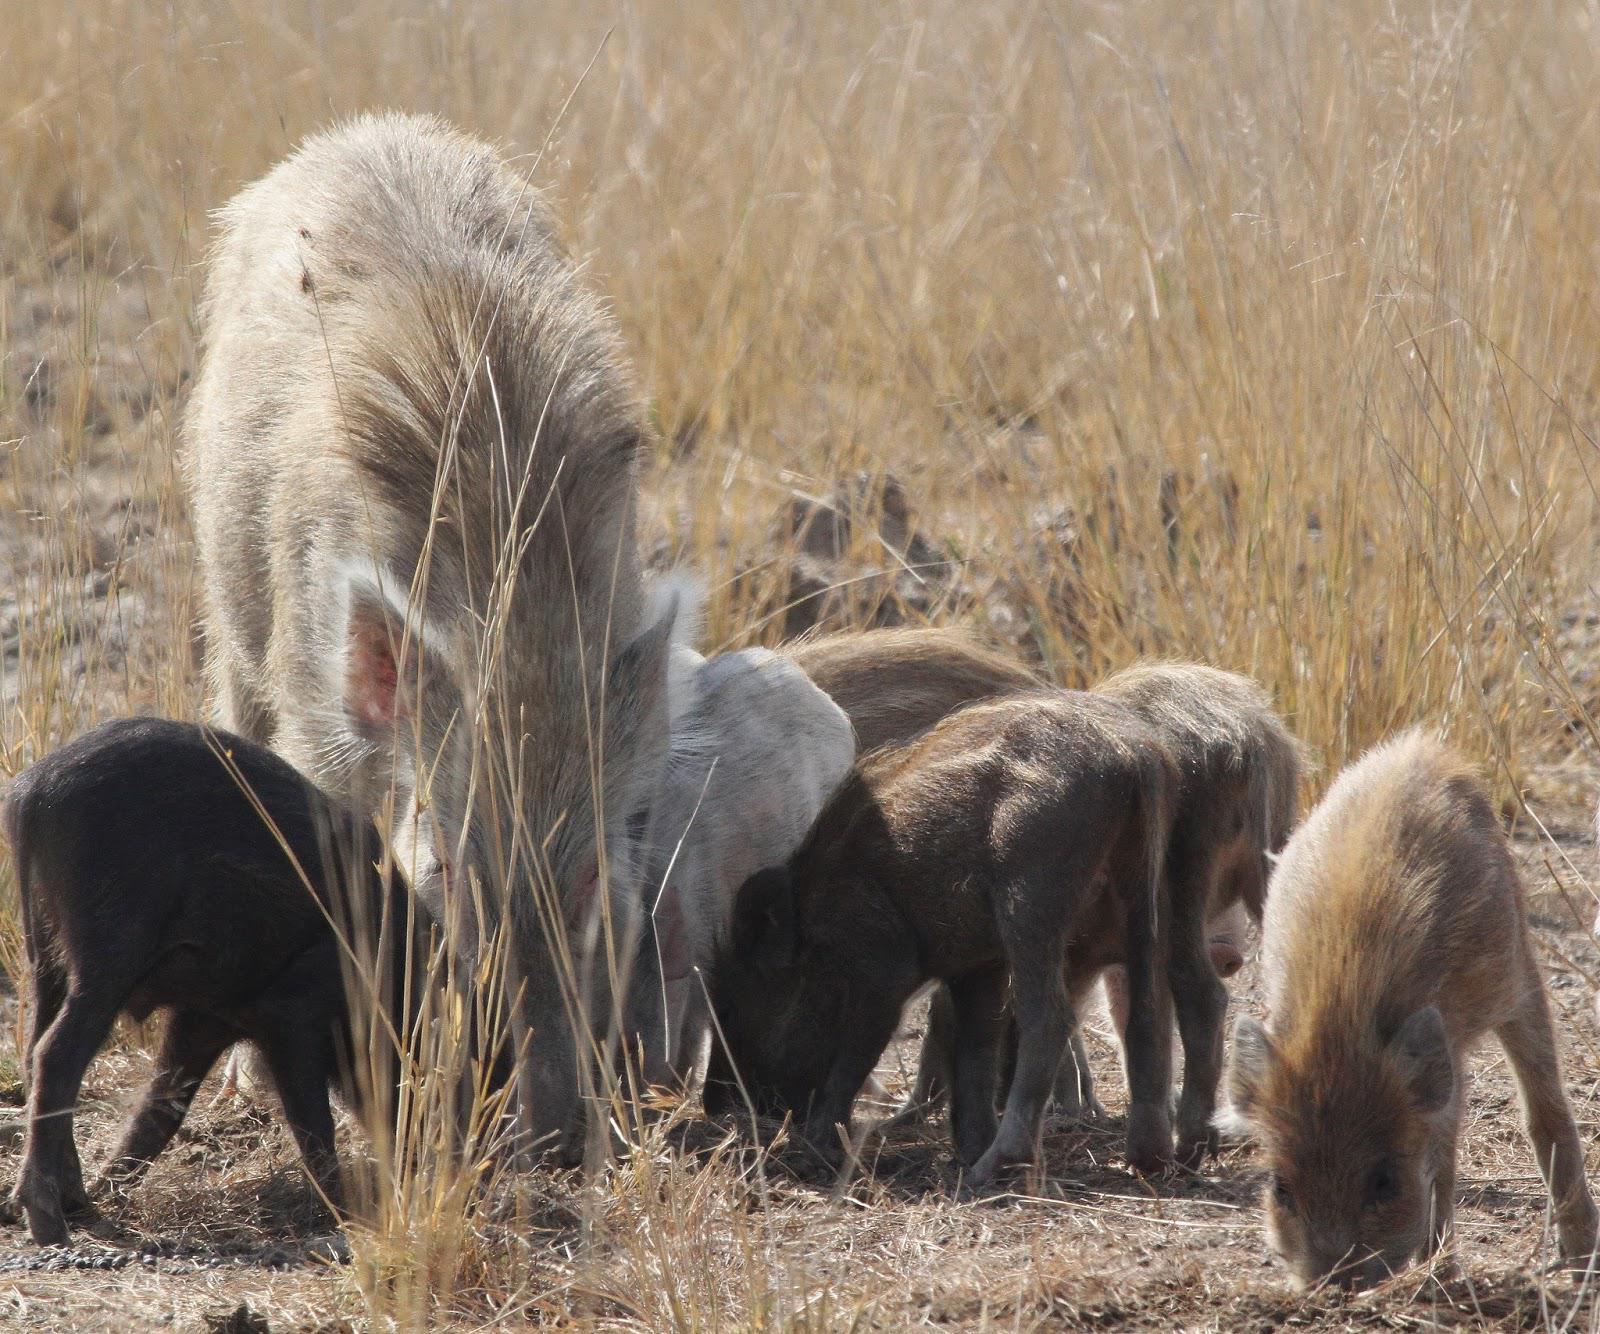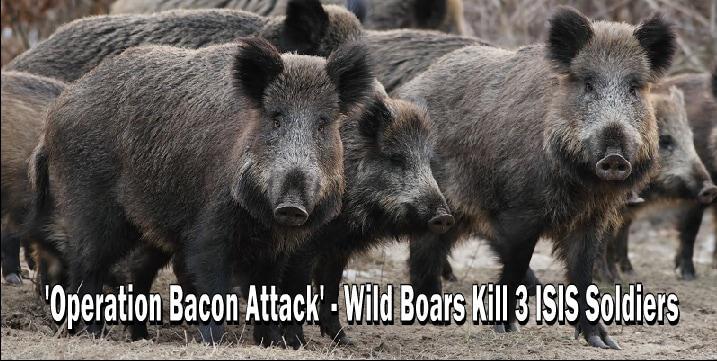The first image is the image on the left, the second image is the image on the right. Examine the images to the left and right. Is the description "There are no more than 4 animals in the image on the right." accurate? Answer yes or no. No. The first image is the image on the left, the second image is the image on the right. Given the left and right images, does the statement "One of the images contains exactly three boars." hold true? Answer yes or no. No. 